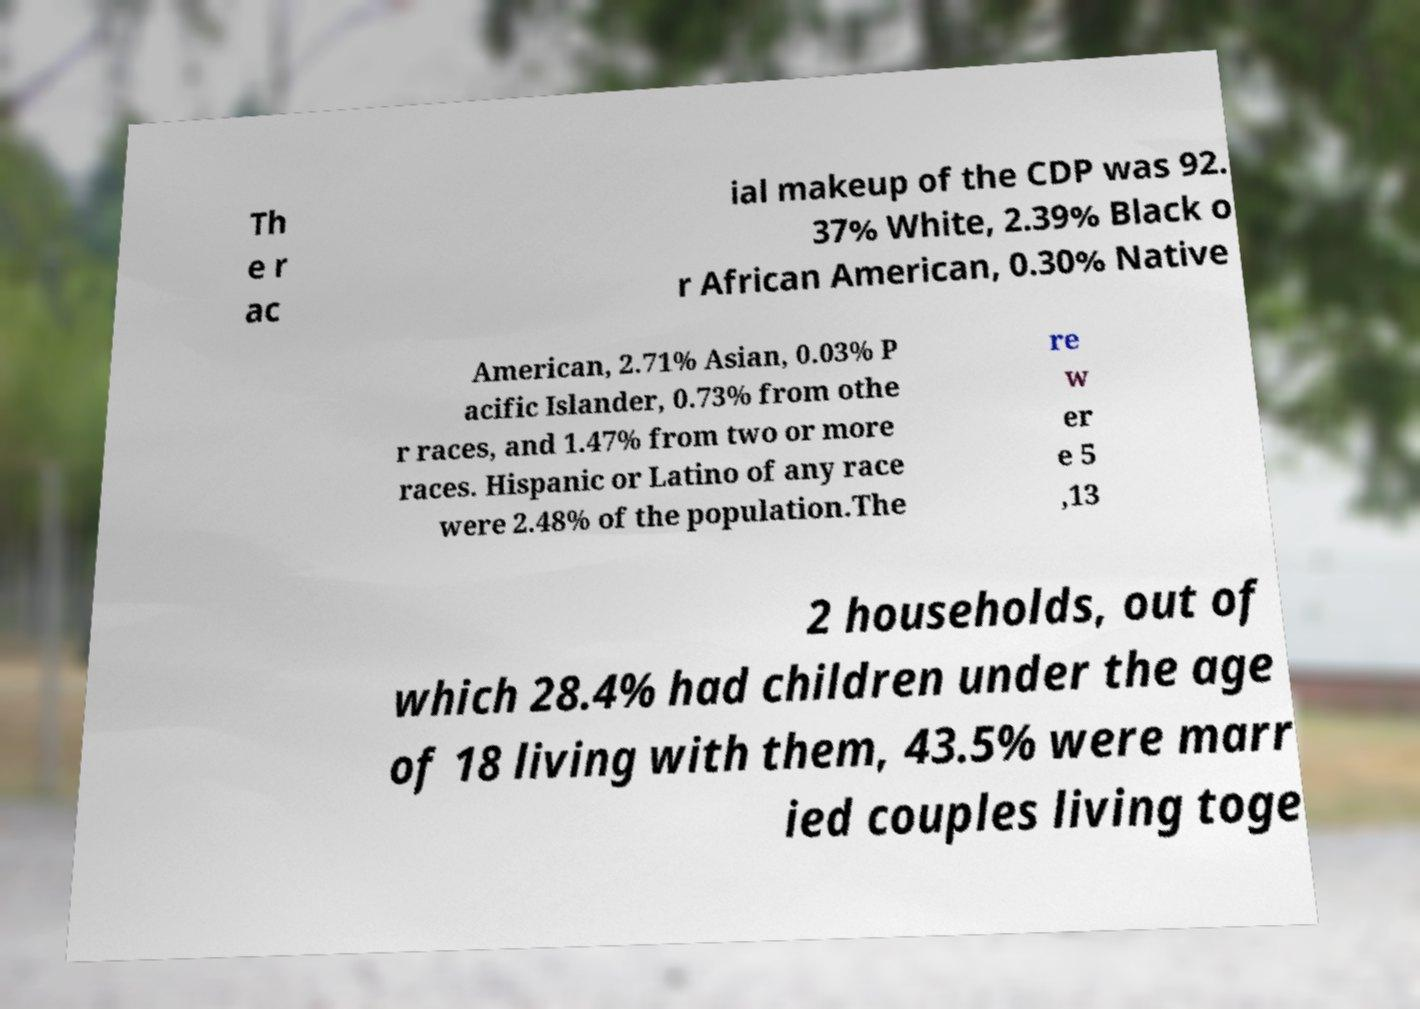For documentation purposes, I need the text within this image transcribed. Could you provide that? Th e r ac ial makeup of the CDP was 92. 37% White, 2.39% Black o r African American, 0.30% Native American, 2.71% Asian, 0.03% P acific Islander, 0.73% from othe r races, and 1.47% from two or more races. Hispanic or Latino of any race were 2.48% of the population.The re w er e 5 ,13 2 households, out of which 28.4% had children under the age of 18 living with them, 43.5% were marr ied couples living toge 